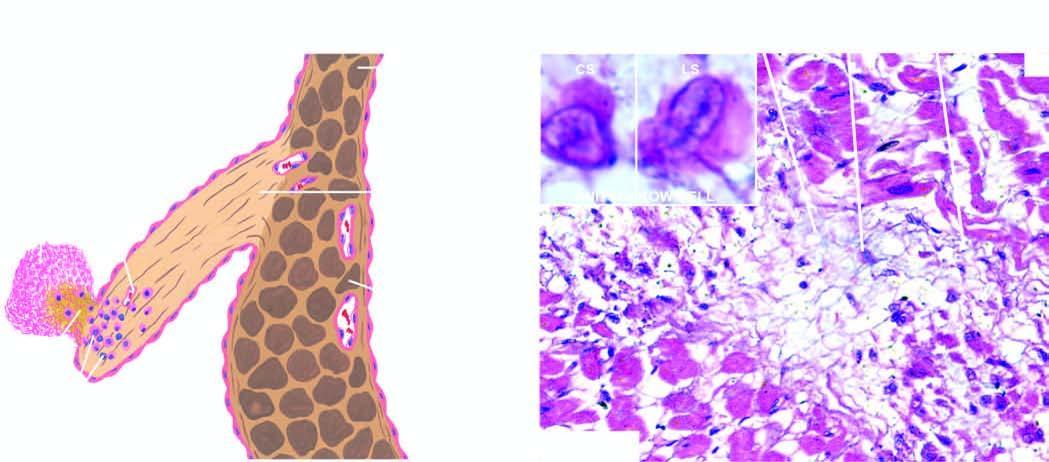does inbox show an anitschkow cell in cross section and in longitudinal section?
Answer the question using a single word or phrase. Yes 